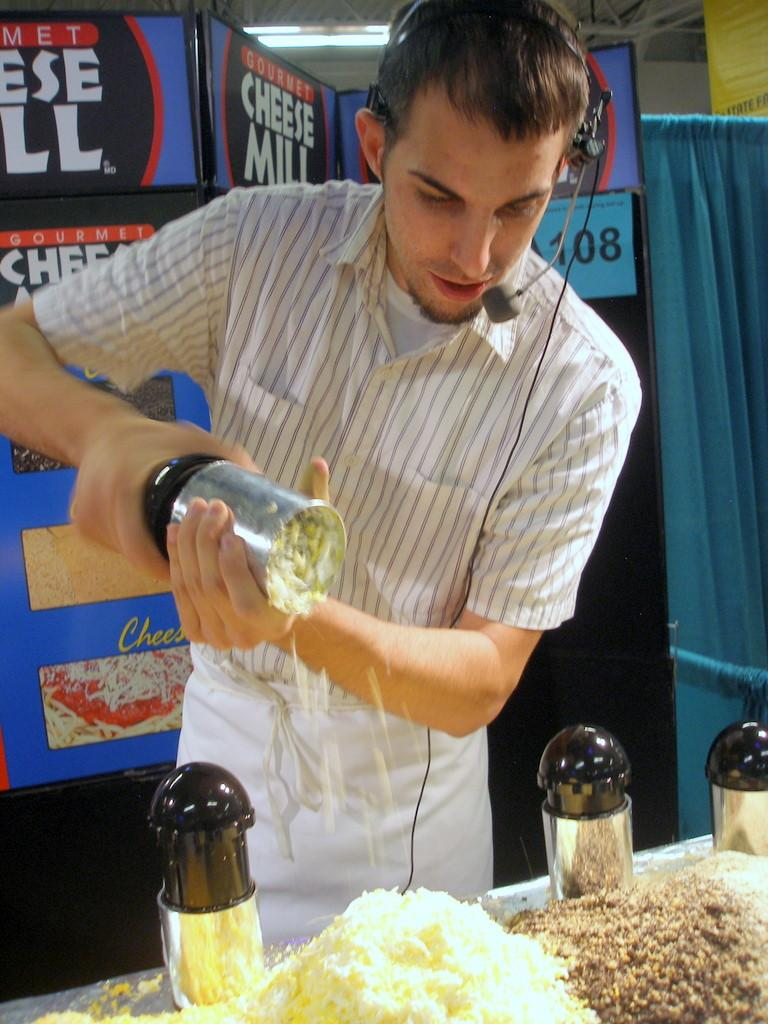<image>
Write a terse but informative summary of the picture. Chef shredding the Cheese of the  Cheese Mill Restaurant. 